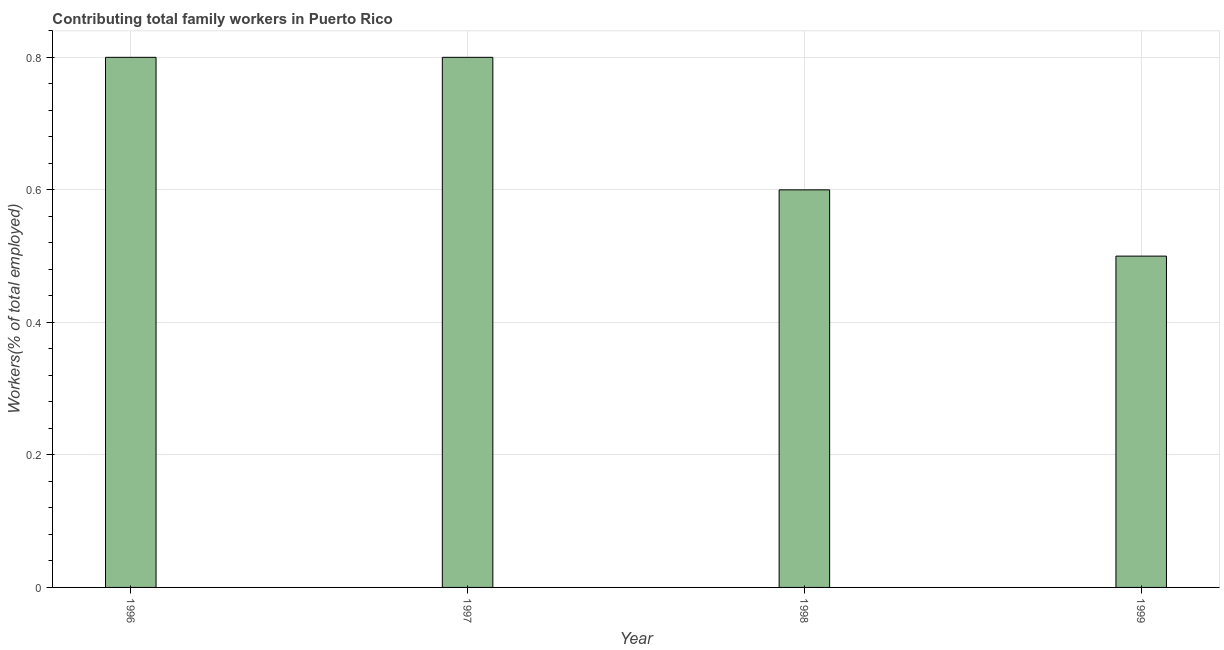Does the graph contain any zero values?
Give a very brief answer. No. Does the graph contain grids?
Your response must be concise. Yes. What is the title of the graph?
Provide a succinct answer. Contributing total family workers in Puerto Rico. What is the label or title of the Y-axis?
Offer a terse response. Workers(% of total employed). What is the contributing family workers in 1997?
Give a very brief answer. 0.8. Across all years, what is the maximum contributing family workers?
Keep it short and to the point. 0.8. Across all years, what is the minimum contributing family workers?
Your answer should be very brief. 0.5. In which year was the contributing family workers minimum?
Make the answer very short. 1999. What is the sum of the contributing family workers?
Offer a terse response. 2.7. What is the difference between the contributing family workers in 1996 and 1999?
Ensure brevity in your answer.  0.3. What is the average contributing family workers per year?
Offer a terse response. 0.68. What is the median contributing family workers?
Make the answer very short. 0.7. In how many years, is the contributing family workers greater than 0.64 %?
Provide a succinct answer. 2. Do a majority of the years between 1999 and 1997 (inclusive) have contributing family workers greater than 0.64 %?
Ensure brevity in your answer.  Yes. What is the ratio of the contributing family workers in 1996 to that in 1997?
Offer a terse response. 1. Is the difference between the contributing family workers in 1996 and 1998 greater than the difference between any two years?
Your response must be concise. No. What is the difference between the highest and the second highest contributing family workers?
Offer a terse response. 0. What is the difference between the highest and the lowest contributing family workers?
Provide a succinct answer. 0.3. Are all the bars in the graph horizontal?
Your answer should be compact. No. How many years are there in the graph?
Provide a succinct answer. 4. What is the difference between two consecutive major ticks on the Y-axis?
Provide a succinct answer. 0.2. Are the values on the major ticks of Y-axis written in scientific E-notation?
Provide a short and direct response. No. What is the Workers(% of total employed) of 1996?
Make the answer very short. 0.8. What is the Workers(% of total employed) of 1997?
Make the answer very short. 0.8. What is the Workers(% of total employed) in 1998?
Ensure brevity in your answer.  0.6. What is the Workers(% of total employed) of 1999?
Give a very brief answer. 0.5. What is the difference between the Workers(% of total employed) in 1996 and 1997?
Your answer should be very brief. 0. What is the difference between the Workers(% of total employed) in 1996 and 1998?
Provide a short and direct response. 0.2. What is the difference between the Workers(% of total employed) in 1996 and 1999?
Give a very brief answer. 0.3. What is the difference between the Workers(% of total employed) in 1997 and 1999?
Offer a terse response. 0.3. What is the ratio of the Workers(% of total employed) in 1996 to that in 1997?
Make the answer very short. 1. What is the ratio of the Workers(% of total employed) in 1996 to that in 1998?
Offer a very short reply. 1.33. What is the ratio of the Workers(% of total employed) in 1997 to that in 1998?
Provide a short and direct response. 1.33. What is the ratio of the Workers(% of total employed) in 1998 to that in 1999?
Give a very brief answer. 1.2. 